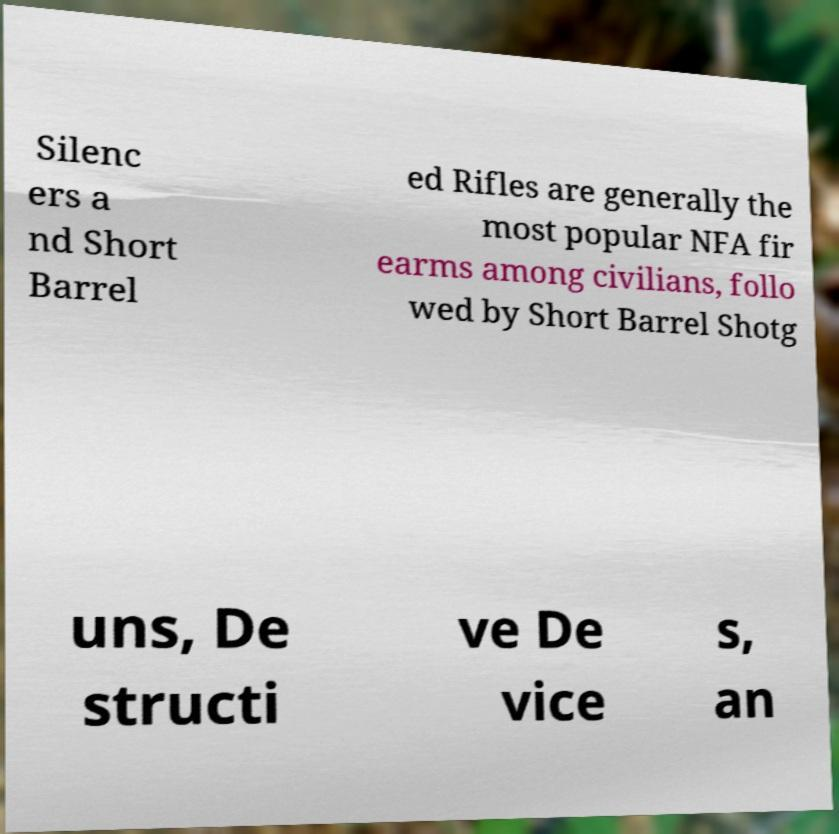What messages or text are displayed in this image? I need them in a readable, typed format. Silenc ers a nd Short Barrel ed Rifles are generally the most popular NFA fir earms among civilians, follo wed by Short Barrel Shotg uns, De structi ve De vice s, an 